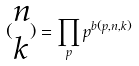<formula> <loc_0><loc_0><loc_500><loc_500>( \begin{matrix} n \\ k \end{matrix} ) = \prod _ { p } p ^ { b ( p , n , k ) }</formula> 